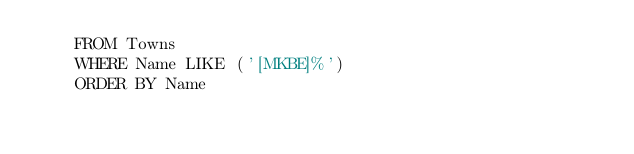<code> <loc_0><loc_0><loc_500><loc_500><_SQL_>    FROM Towns
    WHERE Name LIKE ('[MKBE]%')
    ORDER BY Name</code> 